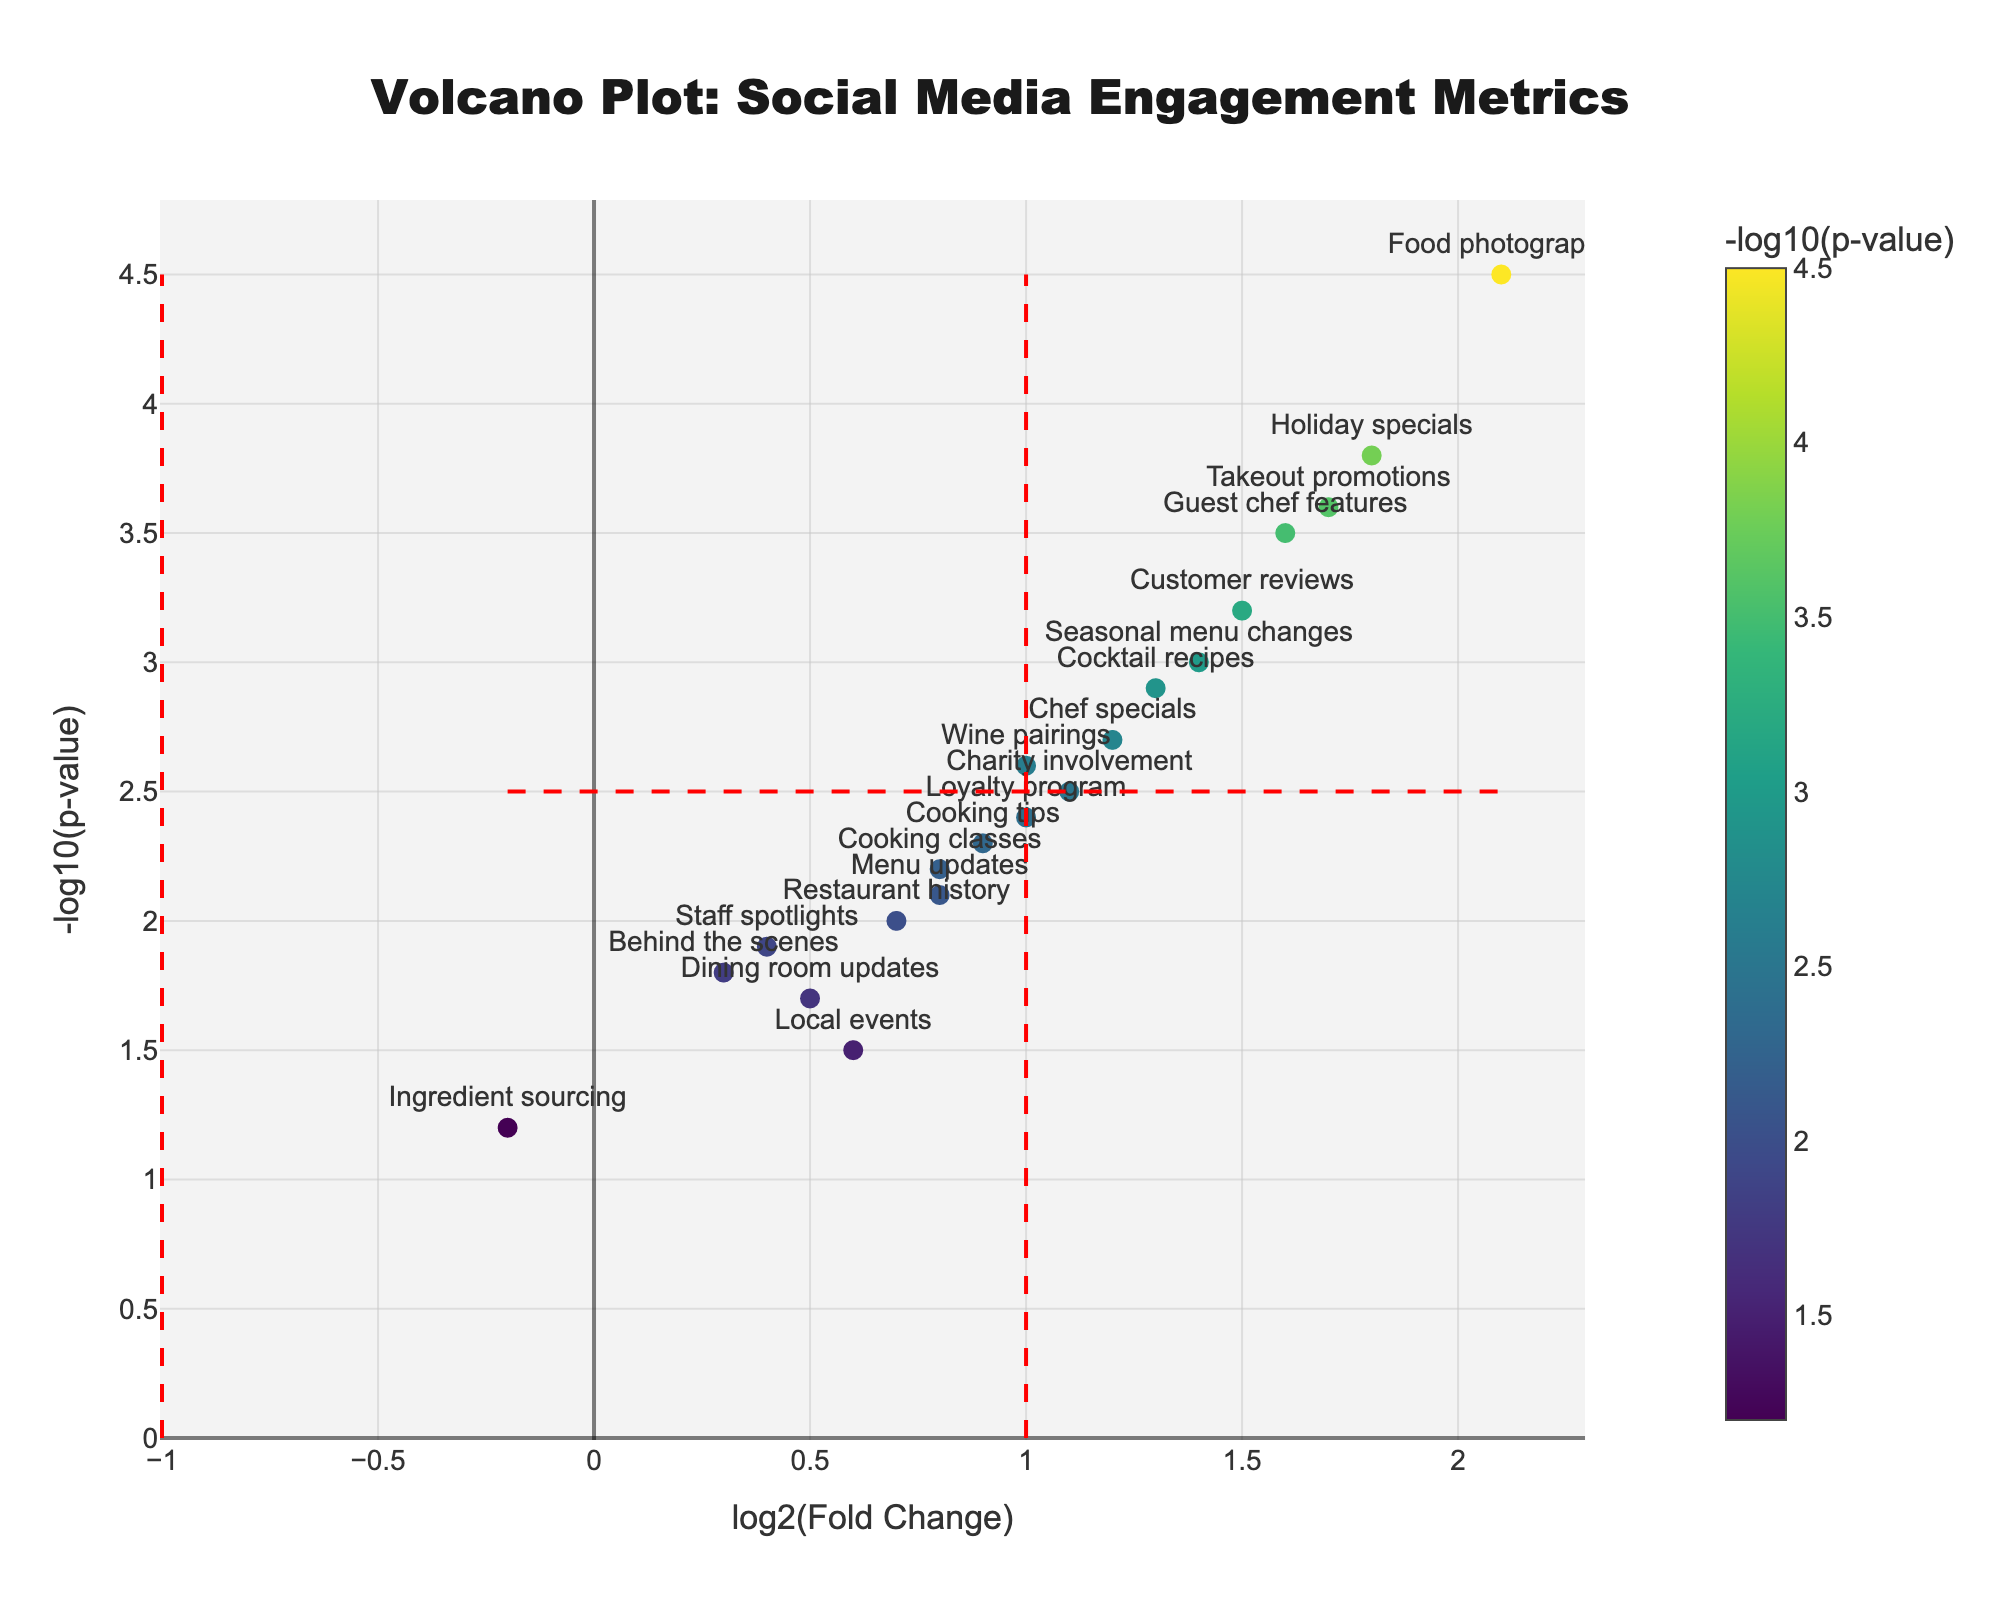what is the highest -log10(p-value) in the figure? Looking at the y-axis, find the highest point among the markers. The data point "Food photography" has the highest value around 4.5.
Answer: 4.5 which post type has the lowest log2(Fold Change)? Examine the x-axis and identify the leftmost data point. "Ingredient sourcing" has the lowest log2(Fold Change) at around -0.2.
Answer: Ingredient sourcing how many post types are above the -log10(p-value) threshold of 2.5? Start from the y-axis at the 2.5 mark and count the number of points above this line. Post types: Customer reviews, Chef specials, Food photography, Holiday specials, Cocktail recipes, Guest chef features, Seasonal menu changes, Takeout promotions, and Wine pairings.
Answer: 9 which post type combines a high log2(Fold Change) and a high -log10(p-value)? Look for data points in the upper right quadrant, particularly those with higher values on both axes. "Food photography" with (log2(FC): 2.1, -log10(p): 4.5) is a prominent example.
Answer: Food photography what is the log2(Fold Change) difference between "Customer reviews" and "Menu updates"? "Customer reviews" log2(FC) is 1.5 and "Menu updates" is 0.8. Subtract Menu updates from Customer reviews: 1.5 - 0.8 = 0.7.
Answer: 0.7 which post type falls closest to the origin of the plot (0,0)? Look for the data point nearest to the intersection of the x and y-axis at (0,0). "Ingredient sourcing" with (-log10(p): 1.2, log2(FC): -0.2) is the closest.
Answer: Ingredient sourcing which post types are significant both statistically and in terms of fold change? Examine the markers that are to the right of log2(Fold Change) threshold 1.0 and above the -log10(p-value) 2.5 line. "Customer reviews", "Chef specials", "Food photography", "Holiday specials", "Guest chef features", "Seasonal menu changes", and "Takeout promotions".
Answer: Customer reviews, Chef specials, Food photography, Holiday specials, Guest chef features, Seasonal menu changes, and Takeout promotions how many post types have a log2(Fold Change) greater than 1.0? Count the data points that are to the right of the vertical threshold line at log2(Fold Change) = 1. Post types that satisfy this criteria: Chef specials, Food photography, Holiday specials, Cocktail recipes, Guest chef features, Seasonal menu changes, Takeout promotions, and Wine pairings.
Answer: 8 